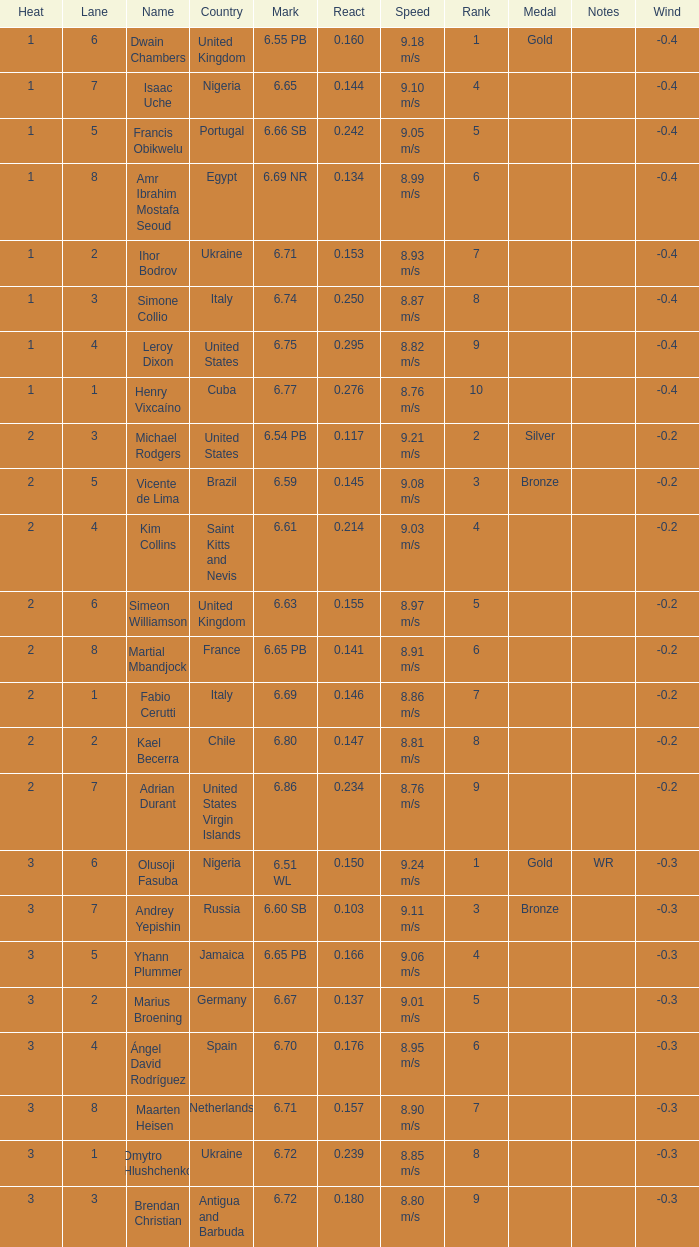Help me parse the entirety of this table. {'header': ['Heat', 'Lane', 'Name', 'Country', 'Mark', 'React', 'Speed', 'Rank', 'Medal', 'Notes', 'Wind'], 'rows': [['1', '6', 'Dwain Chambers', 'United Kingdom', '6.55 PB', '0.160', '9.18 m/s', '1', 'Gold', '', '-0.4'], ['1', '7', 'Isaac Uche', 'Nigeria', '6.65', '0.144', '9.10 m/s', '4', '', '', '-0.4'], ['1', '5', 'Francis Obikwelu', 'Portugal', '6.66 SB', '0.242', '9.05 m/s', '5', '', '', '-0.4'], ['1', '8', 'Amr Ibrahim Mostafa Seoud', 'Egypt', '6.69 NR', '0.134', '8.99 m/s', '6', '', '', '-0.4'], ['1', '2', 'Ihor Bodrov', 'Ukraine', '6.71', '0.153', '8.93 m/s', '7', '', '', '-0.4'], ['1', '3', 'Simone Collio', 'Italy', '6.74', '0.250', '8.87 m/s', '8', '', '', '-0.4'], ['1', '4', 'Leroy Dixon', 'United States', '6.75', '0.295', '8.82 m/s', '9', '', '', '-0.4'], ['1', '1', 'Henry Vixcaíno', 'Cuba', '6.77', '0.276', '8.76 m/s', '10', '', '', '-0.4'], ['2', '3', 'Michael Rodgers', 'United States', '6.54 PB', '0.117', '9.21 m/s', '2', 'Silver', '', '-0.2'], ['2', '5', 'Vicente de Lima', 'Brazil', '6.59', '0.145', '9.08 m/s', '3', 'Bronze', '', '-0.2'], ['2', '4', 'Kim Collins', 'Saint Kitts and Nevis', '6.61', '0.214', '9.03 m/s', '4', '', '', '-0.2'], ['2', '6', 'Simeon Williamson', 'United Kingdom', '6.63', '0.155', '8.97 m/s', '5', '', '', '-0.2'], ['2', '8', 'Martial Mbandjock', 'France', '6.65 PB', '0.141', '8.91 m/s', '6', '', '', '-0.2'], ['2', '1', 'Fabio Cerutti', 'Italy', '6.69', '0.146', '8.86 m/s', '7', '', '', '-0.2'], ['2', '2', 'Kael Becerra', 'Chile', '6.80', '0.147', '8.81 m/s', '8', '', '', '-0.2'], ['2', '7', 'Adrian Durant', 'United States Virgin Islands', '6.86', '0.234', '8.76 m/s', '9', '', '', '-0.2'], ['3', '6', 'Olusoji Fasuba', 'Nigeria', '6.51 WL', '0.150', '9.24 m/s', '1', 'Gold', 'WR', '-0.3'], ['3', '7', 'Andrey Yepishin', 'Russia', '6.60 SB', '0.103', '9.11 m/s', '3', 'Bronze', '', '-0.3'], ['3', '5', 'Yhann Plummer', 'Jamaica', '6.65 PB', '0.166', '9.06 m/s', '4', '', '', '-0.3'], ['3', '2', 'Marius Broening', 'Germany', '6.67', '0.137', '9.01 m/s', '5', '', '', '-0.3'], ['3', '4', 'Ángel David Rodríguez', 'Spain', '6.70', '0.176', '8.95 m/s', '6', '', '', '-0.3'], ['3', '8', 'Maarten Heisen', 'Netherlands', '6.71', '0.157', '8.90 m/s', '7', '', '', '-0.3'], ['3', '1', 'Dmytro Hlushchenko', 'Ukraine', '6.72', '0.239', '8.85 m/s', '8', '', '', '-0.3'], ['3', '3', 'Brendan Christian', 'Antigua and Barbuda', '6.72', '0.180', '8.80 m/s', '9', '', '', '-0.3']]} What is the country when lane equals 5 and react is more than 0.166? Portugal. 